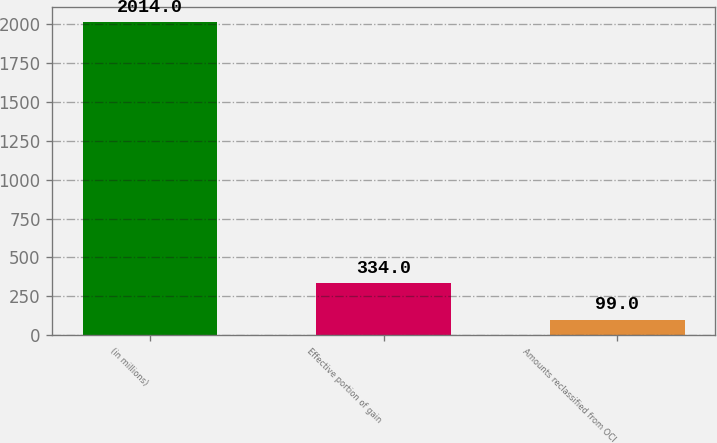<chart> <loc_0><loc_0><loc_500><loc_500><bar_chart><fcel>(in millions)<fcel>Effective portion of gain<fcel>Amounts reclassified from OCI<nl><fcel>2014<fcel>334<fcel>99<nl></chart> 